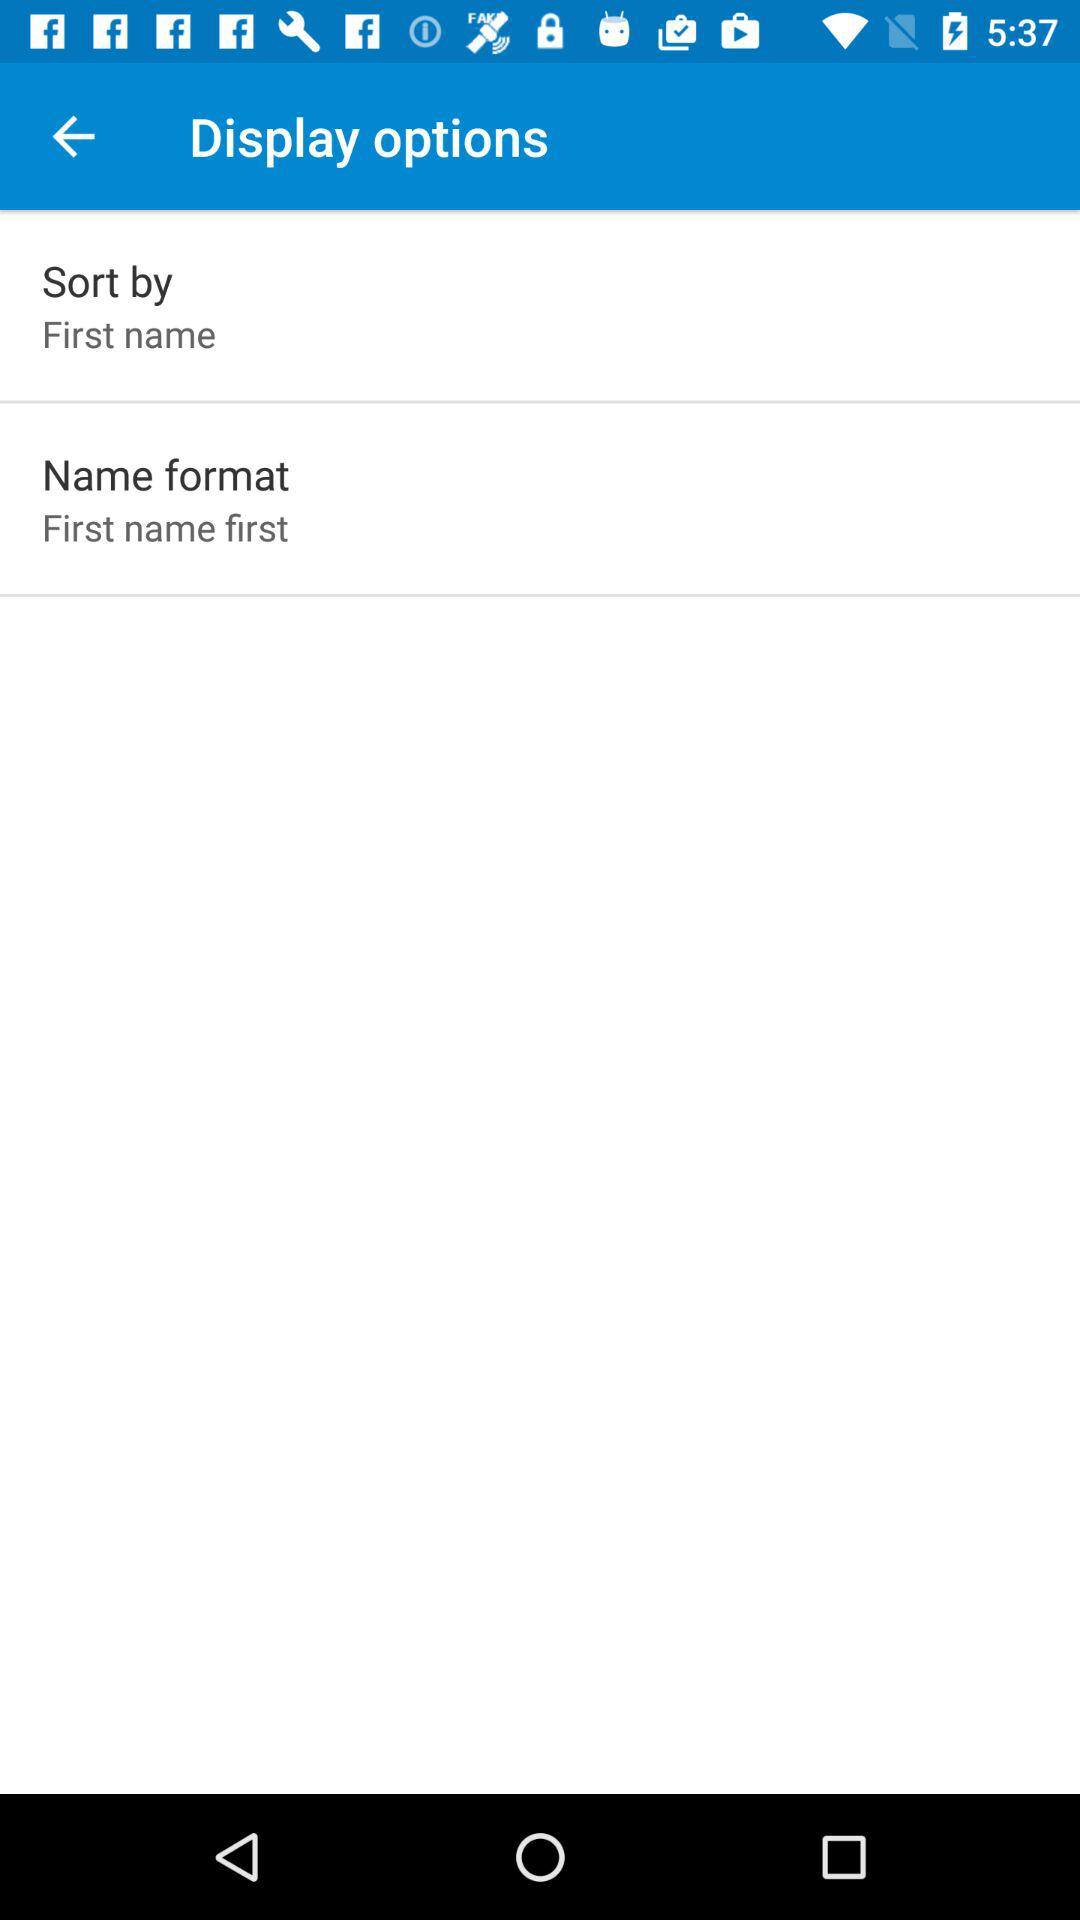What is the display option for name format? The display option is "First name first". 